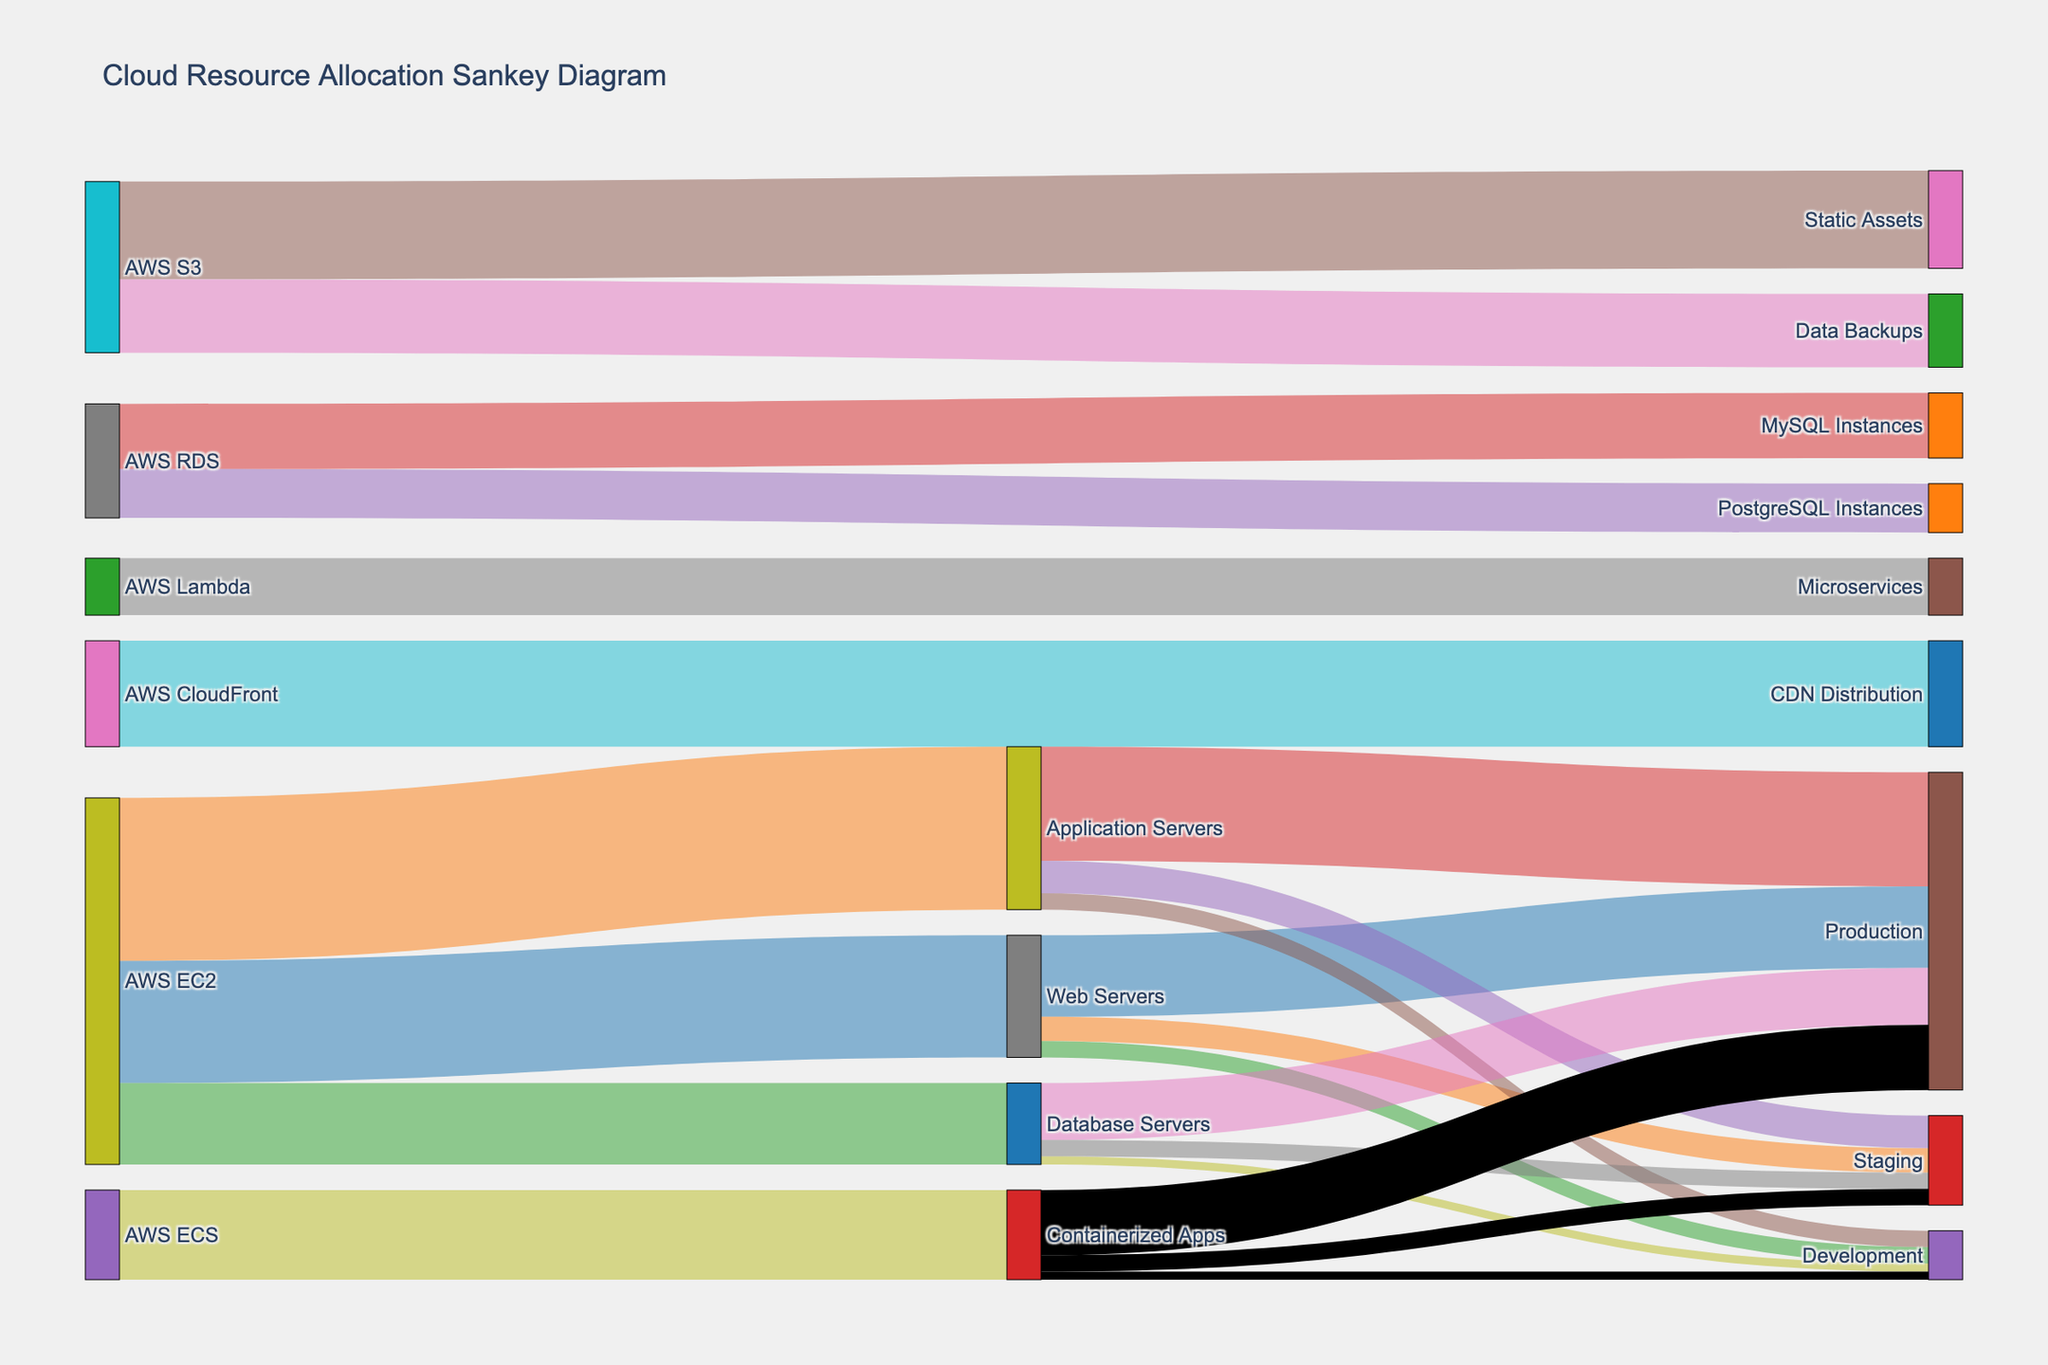what is the title of the figure? The title of the figure is prominently displayed at the top, providing an overview of what the diagram represents. The text size is slightly larger and is bolded to stand out.
Answer: Cloud Resource Allocation Sankey Diagram which cloud service has the highest allocation to Web Servers? Inspect the connections flowing from different sources to the "Web Servers" node. Compare the values associated with each connection to determine the highest value.
Answer: AWS EC2 what is the total allocation of resources from AWS EC2? Look at all connections originating from "AWS EC2" and sum their values: 150 (Web Servers) + 200 (Application Servers) + 100 (Database Servers). Perform the arithmetic to get the answer.
Answer: 450 how many categories are associated with AWS S3? Identify the number of unique target nodes associated with the "AWS S3" source node by counting the connections originating from it.
Answer: 2 what is the combined allocation towards Production from Web Servers and Application Servers? Follow the connections from "Web Servers" and "Application Servers" to "Production". Sum the values: 100 (from Web Servers) + 140 (from Application Servers).
Answer: 240 which service has a greater resource allocation, AWS Lambda or AWS CloudFront? Compare the values of resources allocated directly from "AWS Lambda" and "AWS CloudFront" by inspecting the associated connection values.
Answer: AWS CloudFront how does the allocation to Containerized Apps differ between Staging and Development? Compare the values from the "Containerized Apps" node to its "Staging" and "Development" nodes. Subtract the Development value from the Staging value: 20 - 10.
Answer: 10 what is the total allocation for AWS RDS services? Sum the resources allocated to all services under AWS RDS: 80 (MySQL Instances) + 60 (PostgreSQL Instances). Perform the arithmetic to get the total resource value for RDS.
Answer: 140 which phase has the least resource allocation from Database Servers? Compare the values of resources allocated from "Database Servers" to its three phases: Production, Staging, and Development. Identify the smallest value.
Answer: Development how many unique infrastructure components are involved in this resource allocation diagram? Count all unique nodes listed in the diagram for both source and target columns. Make sure each component is counted once, recognizing overlap where they serve in multiple roles.
Answer: 18 